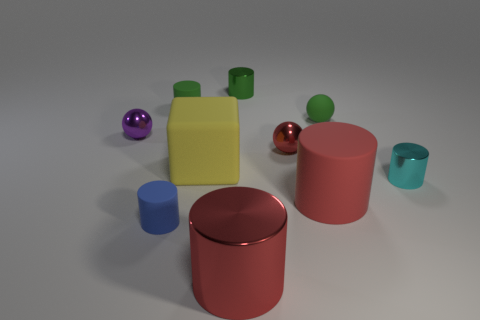Subtract 3 cylinders. How many cylinders are left? 3 Subtract all small blue rubber cylinders. How many cylinders are left? 5 Subtract all cyan cylinders. How many cylinders are left? 5 Subtract all gray cylinders. Subtract all blue balls. How many cylinders are left? 6 Subtract all cylinders. How many objects are left? 4 Add 4 tiny green metallic things. How many tiny green metallic things are left? 5 Add 9 cyan spheres. How many cyan spheres exist? 9 Subtract 1 yellow blocks. How many objects are left? 9 Subtract all blue objects. Subtract all blue metal cylinders. How many objects are left? 9 